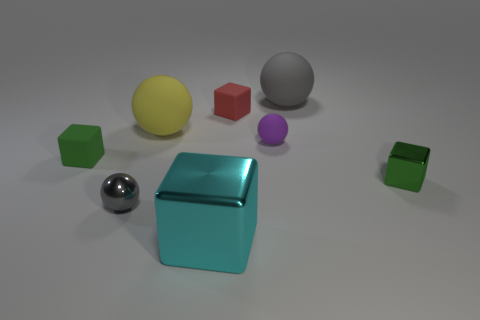Add 2 matte things. How many objects exist? 10 Subtract all big gray spheres. Subtract all red things. How many objects are left? 6 Add 7 tiny gray balls. How many tiny gray balls are left? 8 Add 2 cyan metallic cylinders. How many cyan metallic cylinders exist? 2 Subtract 0 brown blocks. How many objects are left? 8 